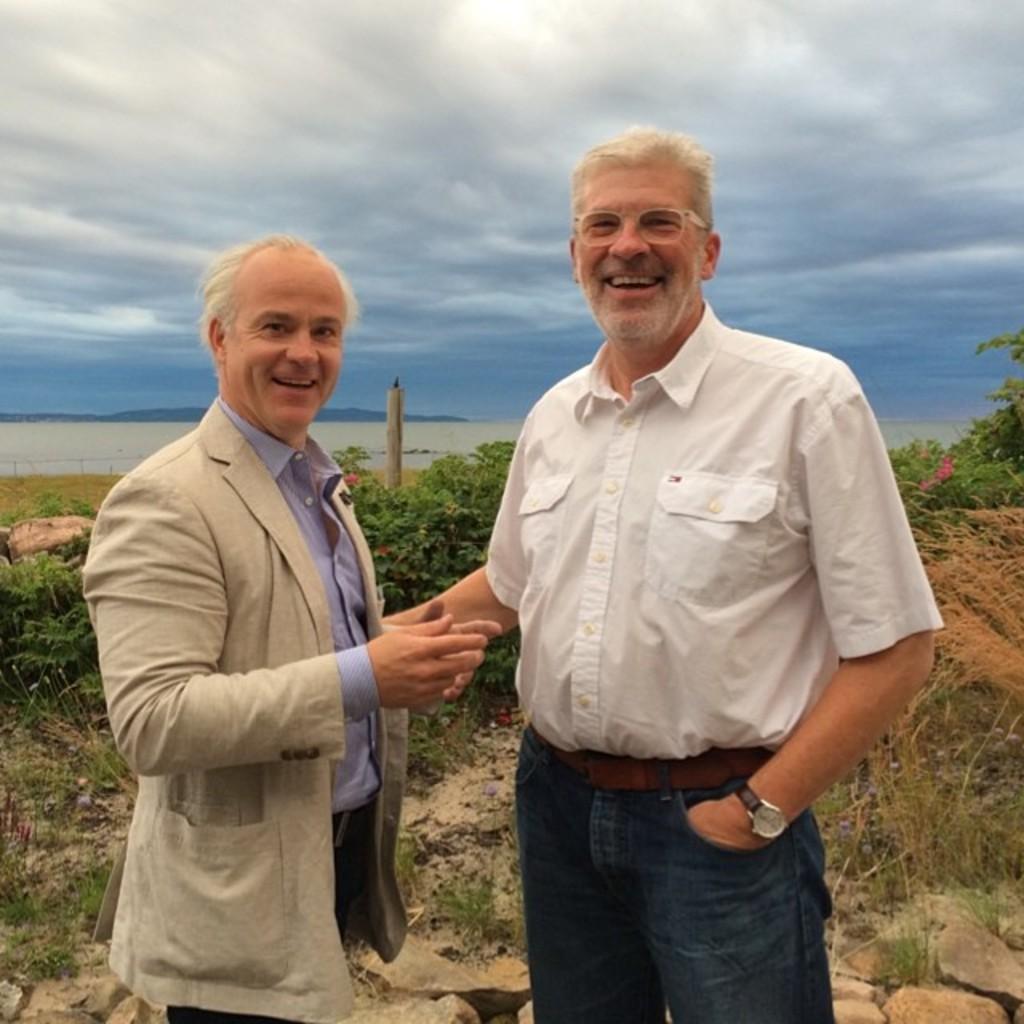In one or two sentences, can you explain what this image depicts? In this image there are persons standing in the center and smiling. In the background there are trees, there is grass on the ground, and the sky is cloudy. 